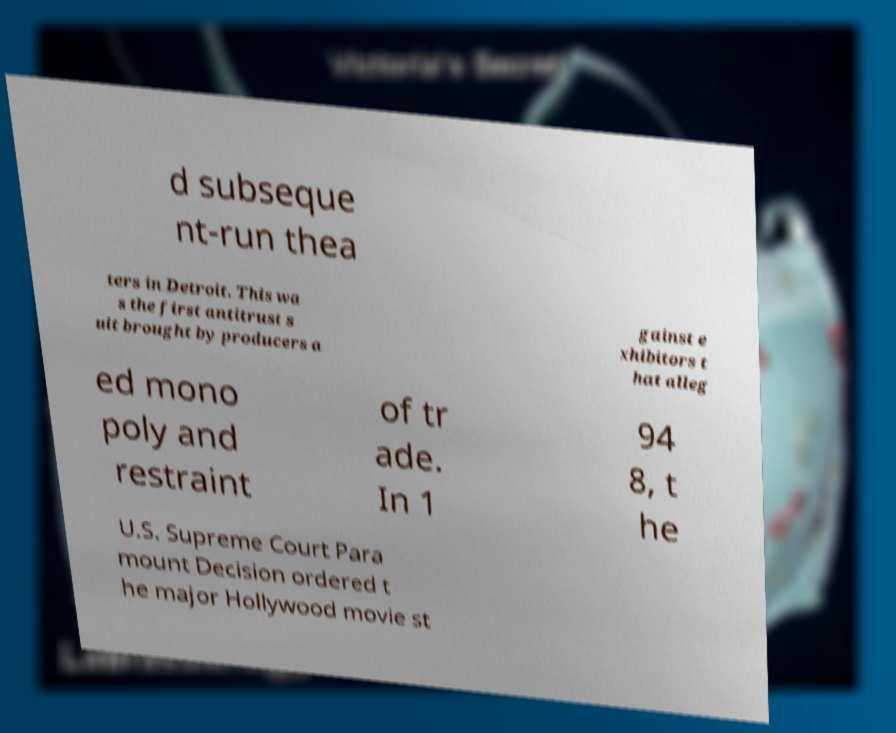Could you extract and type out the text from this image? d subseque nt-run thea ters in Detroit. This wa s the first antitrust s uit brought by producers a gainst e xhibitors t hat alleg ed mono poly and restraint of tr ade. In 1 94 8, t he U.S. Supreme Court Para mount Decision ordered t he major Hollywood movie st 